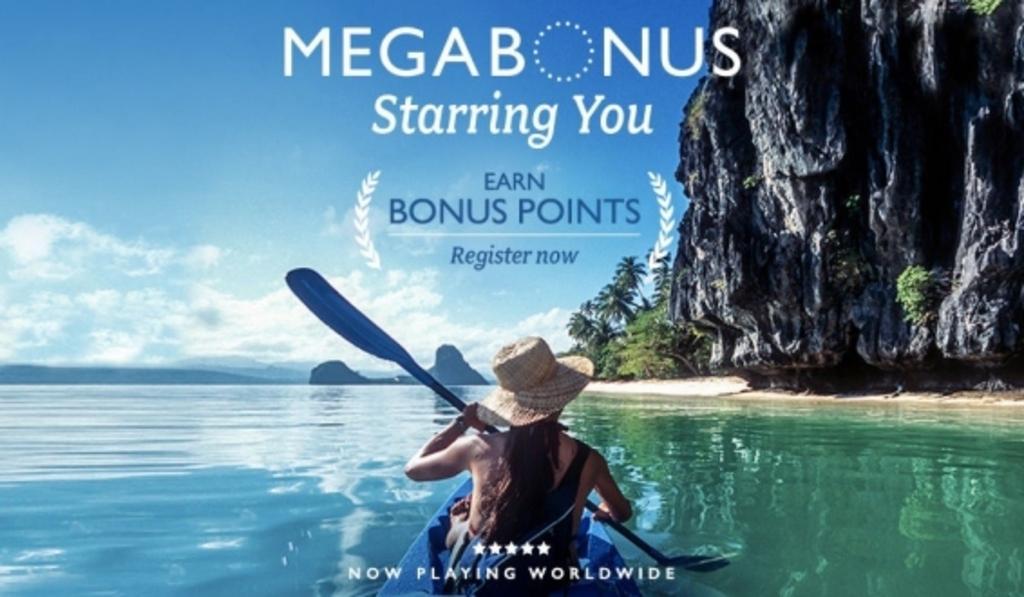How would you summarize this image in a sentence or two? In front of the image there is a person rowing the boat in the water. In the background of the image there are trees, mountains. At the top of the image there are clouds in the sky. There is some text on the image. 